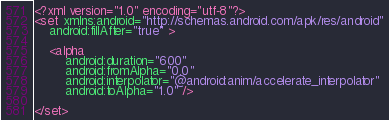Convert code to text. <code><loc_0><loc_0><loc_500><loc_500><_XML_><?xml version="1.0" encoding="utf-8"?>
<set xmlns:android="http://schemas.android.com/apk/res/android"
    android:fillAfter="true" >

    <alpha
        android:duration="600"
        android:fromAlpha="0.0"
        android:interpolator="@android:anim/accelerate_interpolator"
        android:toAlpha="1.0" />

</set></code> 